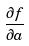<formula> <loc_0><loc_0><loc_500><loc_500>\frac { \partial f } { \partial a }</formula> 